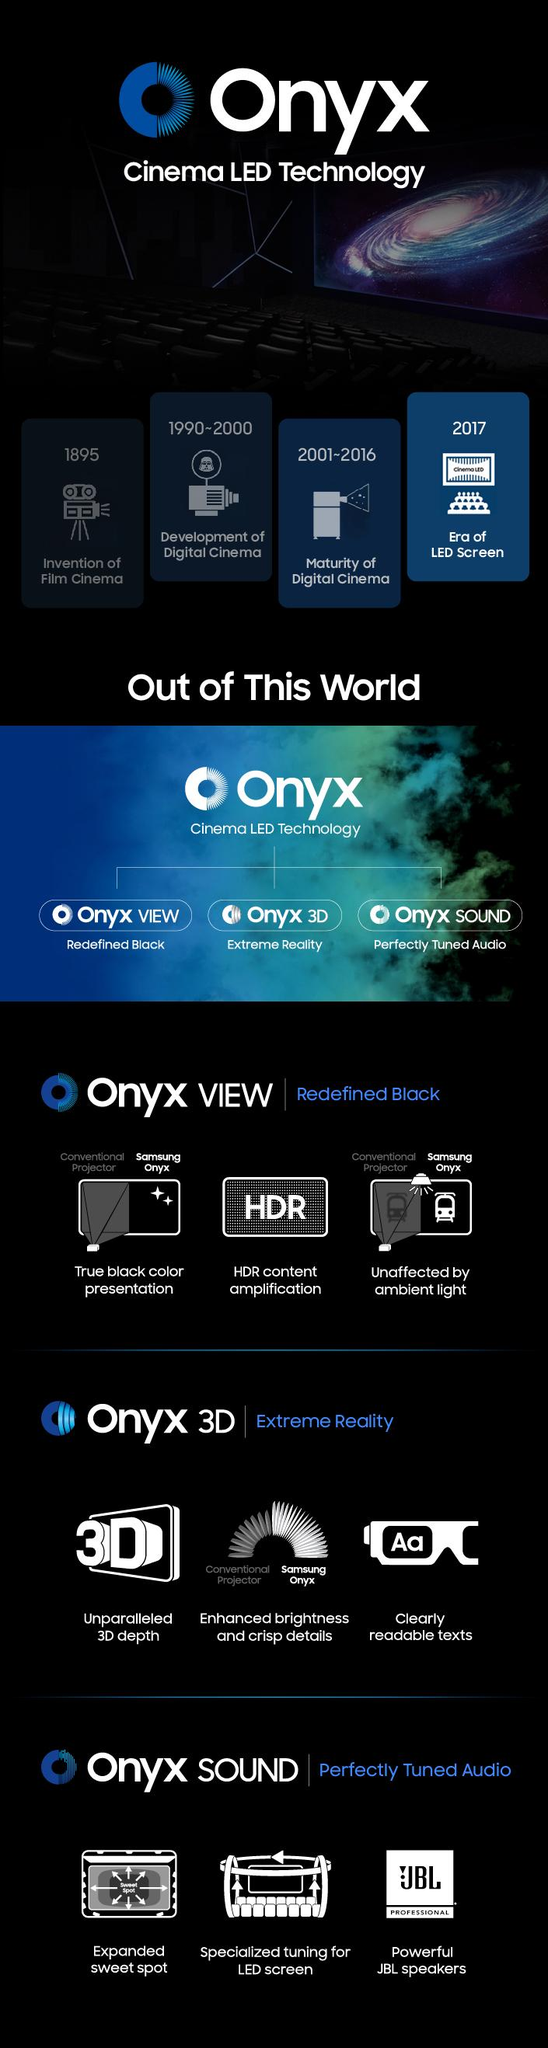Point out several critical features in this image. In 2017, LED screens were introduced in cinemas, marking a significant change in the way movies are presented to audiences. Film cinema was invented in 1895. 